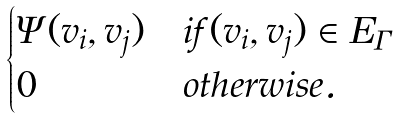<formula> <loc_0><loc_0><loc_500><loc_500>\begin{cases} \Psi ( v _ { i } , v _ { j } ) & i f ( v _ { i } , v _ { j } ) \in E _ { \Gamma } \\ 0 & o t h e r w i s e . \end{cases}</formula> 